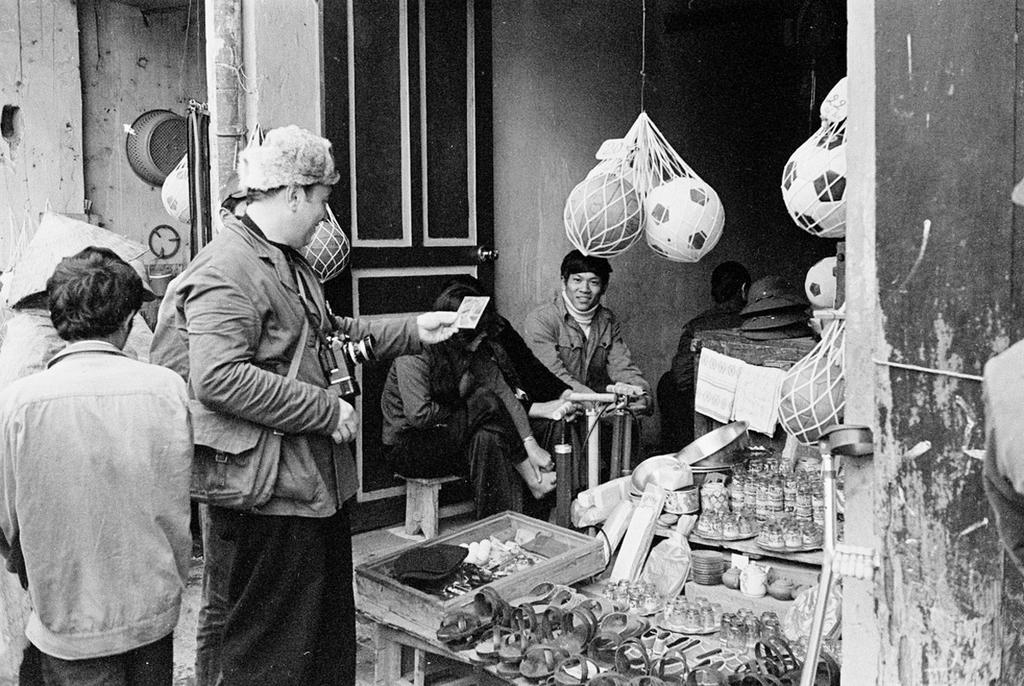Who or what is present in the image? There are people in the image. What can be seen on the right side of the image? There are objects on a table on the right side of the image. How is the image presented in terms of color? The image is in black and white color. What type of mint is growing on the table in the image? There is no mint present in the image; it is a black and white image with people and objects on a table. 